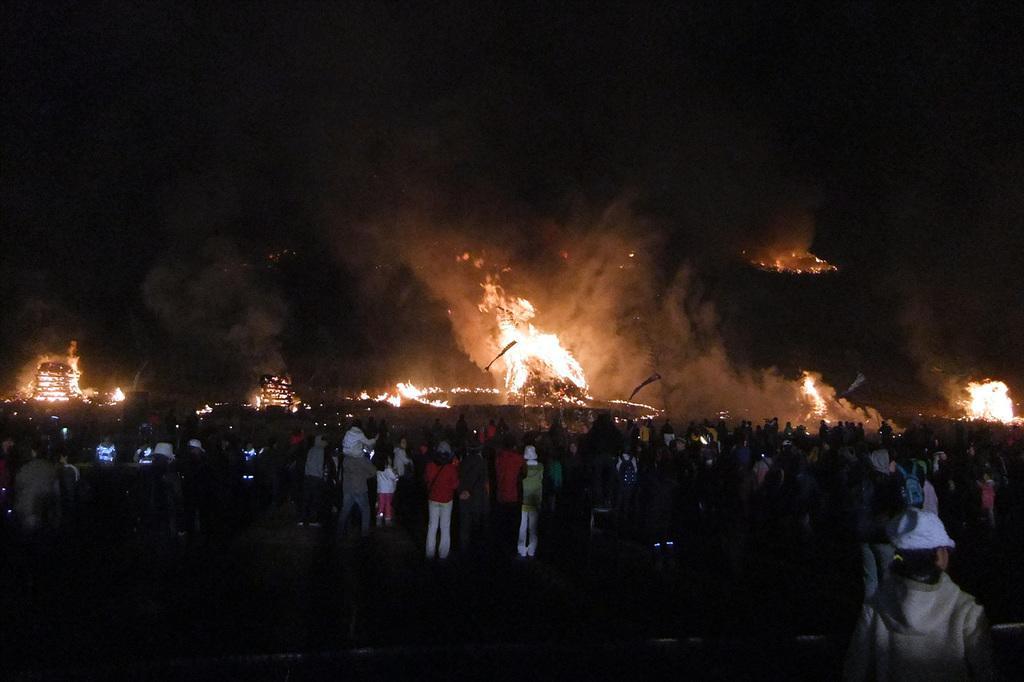Describe this image in one or two sentences. In the center of the image there are people. In the background of the image there is fire. At the top of the image there is sky. 